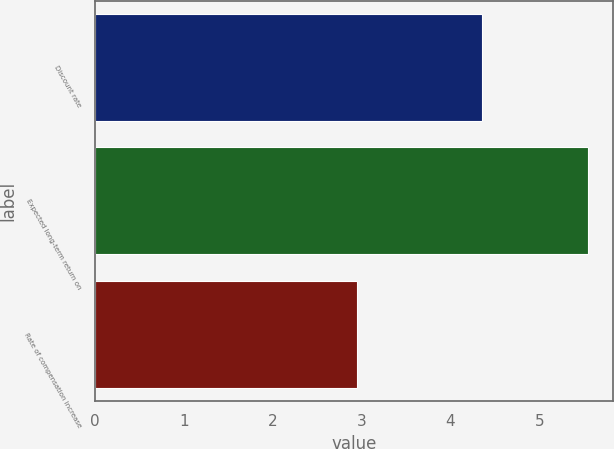<chart> <loc_0><loc_0><loc_500><loc_500><bar_chart><fcel>Discount rate<fcel>Expected long-term return on<fcel>Rate of compensation increase<nl><fcel>4.35<fcel>5.55<fcel>2.95<nl></chart> 